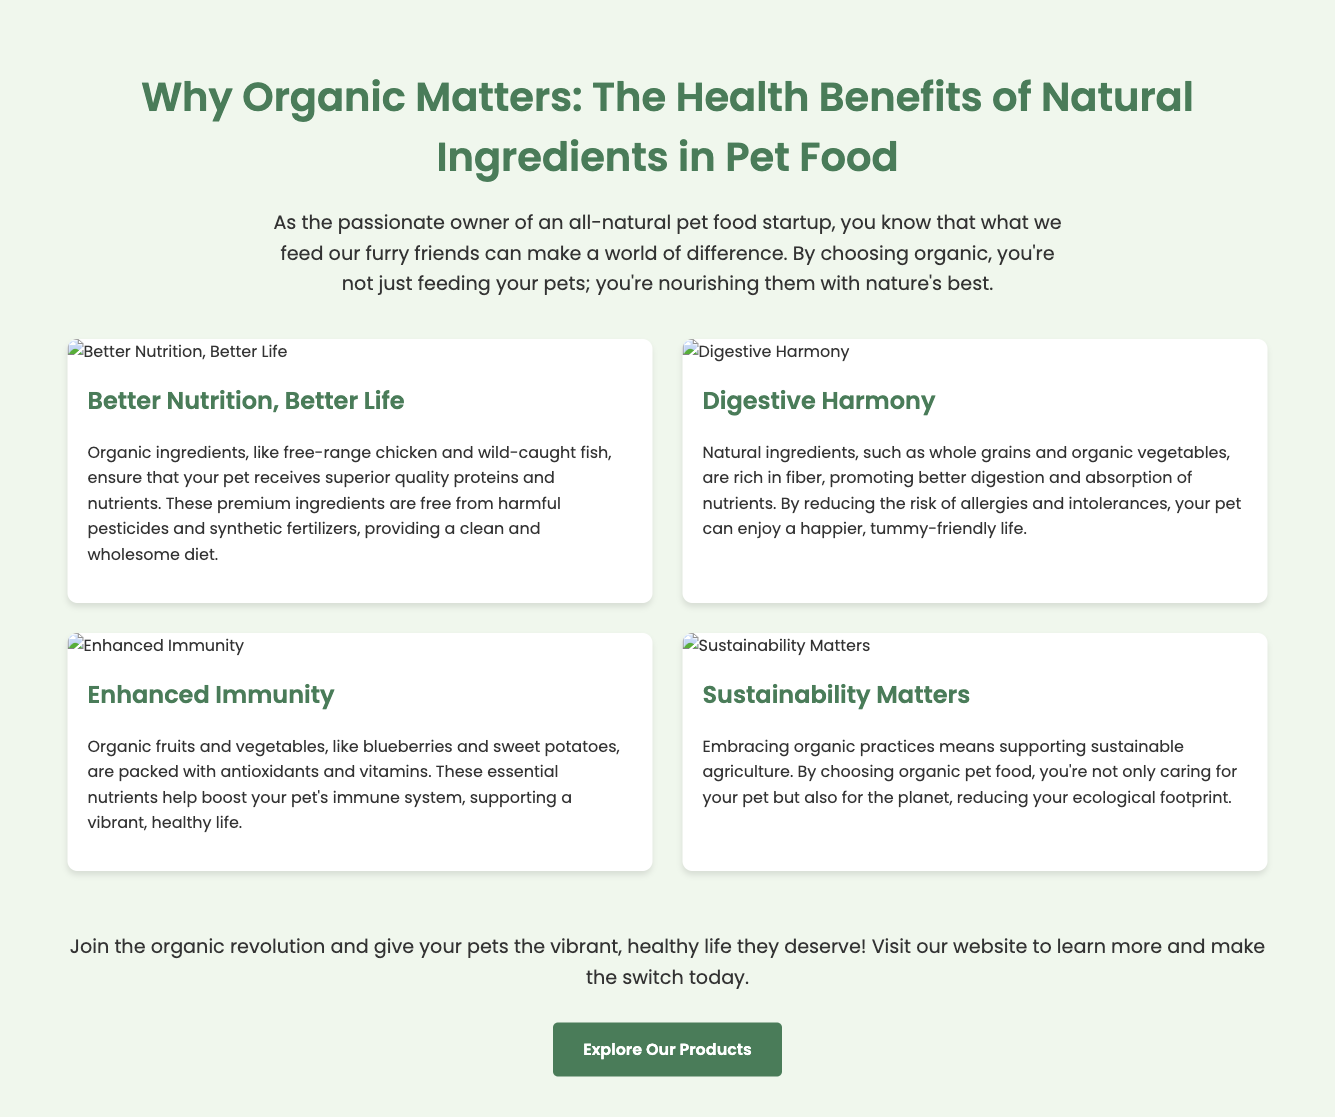What is the title of the advertisement? The title of the advertisement is prominently displayed at the top of the document, highlighting its main theme.
Answer: Why Organic Matters: The Health Benefits of Natural Ingredients in Pet Food How many health benefits of organic pet food are mentioned? The document lists four distinct benefits of organic pet food within the content sections.
Answer: Four What ingredient ensures superior nutrition for pets? The document specifically mentions "free-range chicken" and "wild-caught fish" as ingredients that provide better nutrition.
Answer: Free-range chicken and wild-caught fish Which benefit emphasizes promoting better digestion? One of the benefits explicitly focuses on digestive health, due to the inclusion of certain natural ingredients.
Answer: Digestive Harmony What is the main call to action in the advertisement? The advertisement concludes with a clear invitation to explore products, encouraging visitors to take a next step.
Answer: Explore Our Products Which organic ingredient is noted for enhancing immunity? The advertisement specifically mentions "blueberries and sweet potatoes" as key ingredients for boosting immunity.
Answer: Blueberries and sweet potatoes What color is suggested as the brand's theme? The document uses a specific color throughout its headings and accents, indicating brand consistency in visuals.
Answer: Green What is highlighted as a benefit of choosing organic pet food? The advertisement outlines a key advantage related to environmental impact and sustainable practices in agriculture.
Answer: Sustainability Matters 